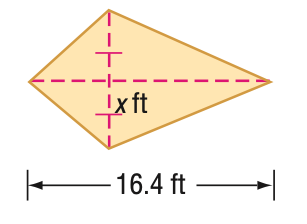Answer the mathemtical geometry problem and directly provide the correct option letter.
Question: Find x. A = 104 ft^2.
Choices: A: 6.3 B: 6.5 C: 7.4 D: 13.0 A 